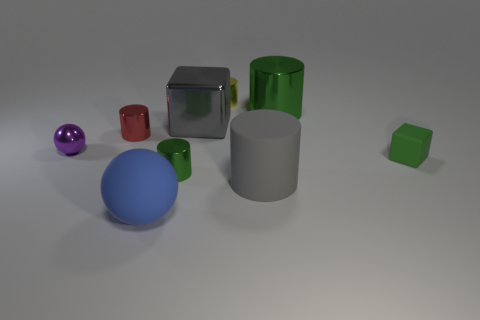Subtract all small red shiny cylinders. How many cylinders are left? 4 Subtract all yellow cylinders. How many cylinders are left? 4 Subtract 1 green cubes. How many objects are left? 8 Subtract all cylinders. How many objects are left? 4 Subtract 1 cylinders. How many cylinders are left? 4 Subtract all gray blocks. Subtract all cyan cylinders. How many blocks are left? 1 Subtract all blue cylinders. How many purple balls are left? 1 Subtract all green shiny things. Subtract all green rubber objects. How many objects are left? 6 Add 1 tiny red objects. How many tiny red objects are left? 2 Add 5 big green metallic objects. How many big green metallic objects exist? 6 